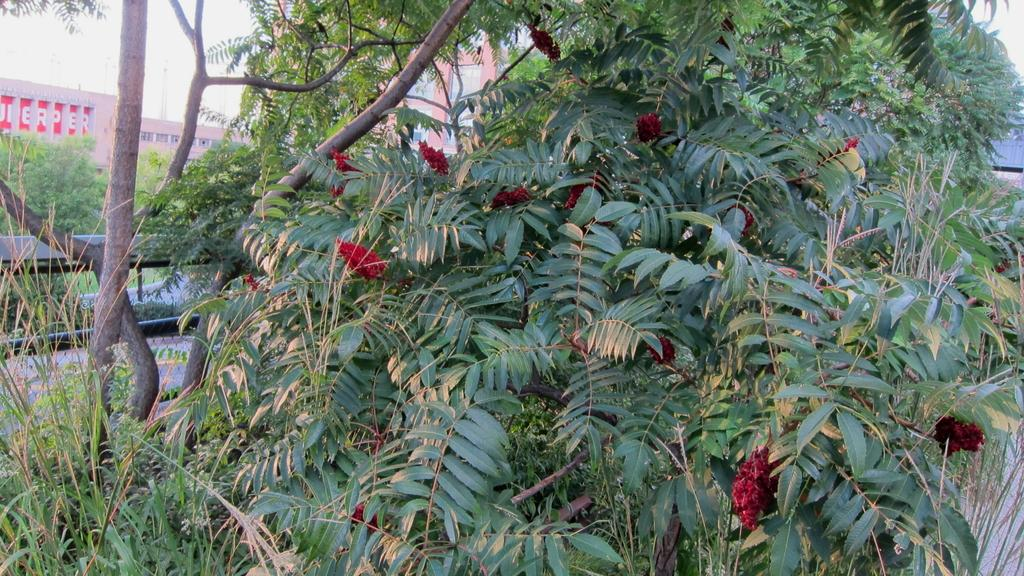What type of plant is featured in the image? There is a tree with flowers in the image. What objects are located behind the tree? There are rods behind the tree. What structure can be seen behind the tree and rods? There is a building visible behind the tree. What part of the natural environment is visible in the image? The sky is visible in the image. What type of treatment is being administered to the tree in the image? There is no treatment being administered to the tree in the image; it is simply a tree with flowers. 